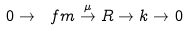Convert formula to latex. <formula><loc_0><loc_0><loc_500><loc_500>0 \rightarrow \ f m \stackrel { \mu } { \rightarrow } R \rightarrow k \rightarrow 0</formula> 